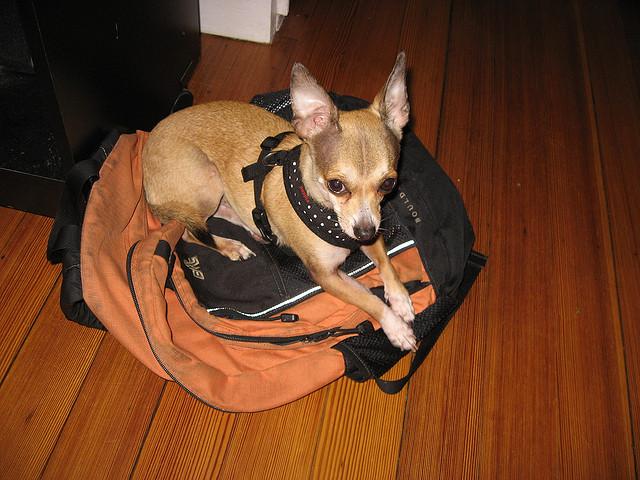Is the dog guarding the bag?
Quick response, please. Yes. What is the dog laying on?
Give a very brief answer. Backpack. What kind of animal is this?
Short answer required. Dog. What breed is the dog?
Keep it brief. Chihuahua. 